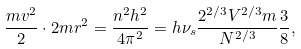Convert formula to latex. <formula><loc_0><loc_0><loc_500><loc_500>\frac { m v ^ { 2 } } { 2 } \cdot 2 m r ^ { 2 } = \frac { n ^ { 2 } h ^ { 2 } } { 4 \pi ^ { 2 } } = h \nu _ { s } \frac { 2 ^ { 2 / 3 } V ^ { 2 / 3 } m } { N ^ { 2 / 3 } } \frac { 3 } { 8 } ,</formula> 